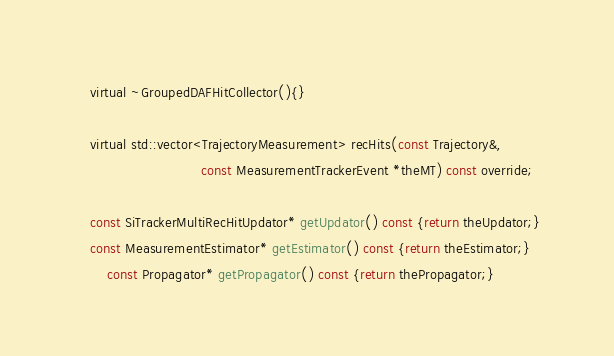<code> <loc_0><loc_0><loc_500><loc_500><_C_>	virtual ~GroupedDAFHitCollector(){}

	virtual std::vector<TrajectoryMeasurement> recHits(const Trajectory&, 
							   const MeasurementTrackerEvent *theMT) const override;

	const SiTrackerMultiRecHitUpdator* getUpdator() const {return theUpdator;}
	const MeasurementEstimator* getEstimator() const {return theEstimator;}
        const Propagator* getPropagator() const {return thePropagator;}</code> 